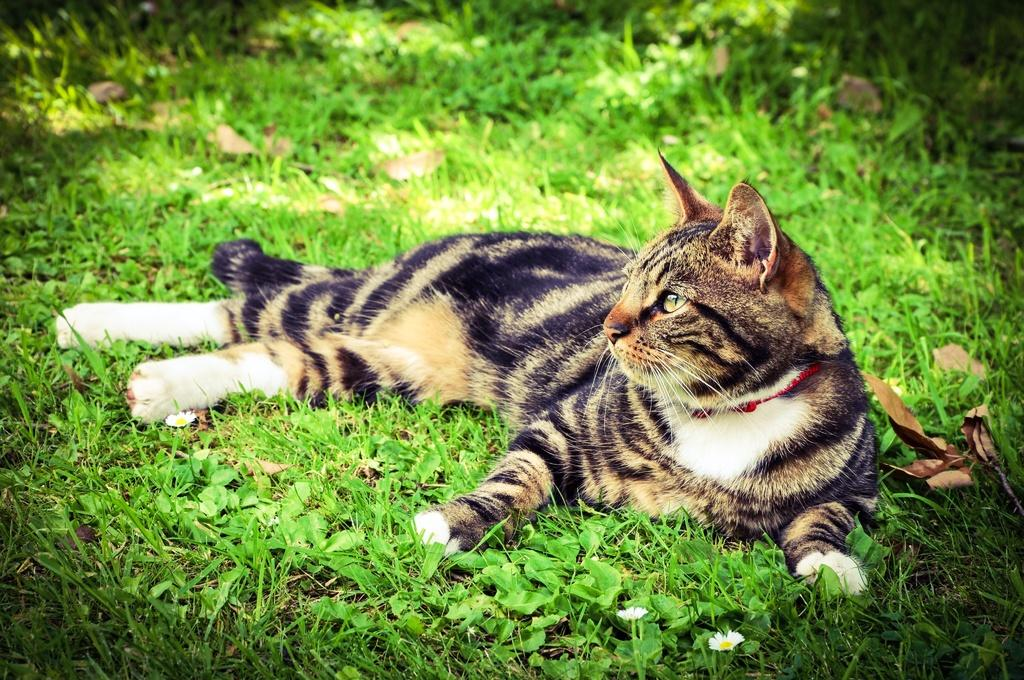What animal can be seen in the image? There is a cat in the image. What is the cat doing in the image? The cat is laying on the grass. What colors can be seen on the cat's fur? The cat has black, brown, and white colors. What type of heart can be seen beating in the cat's chest in the image? There is no heart visible in the image, and it is not possible to see the cat's internal organs. 